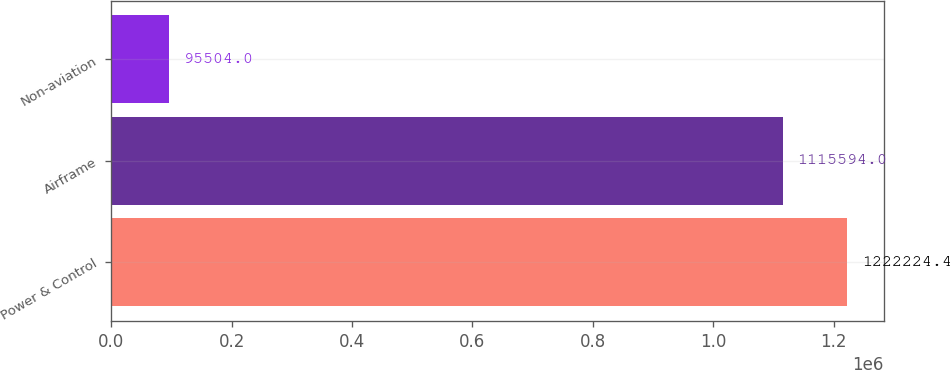<chart> <loc_0><loc_0><loc_500><loc_500><bar_chart><fcel>Power & Control<fcel>Airframe<fcel>Non-aviation<nl><fcel>1.22222e+06<fcel>1.11559e+06<fcel>95504<nl></chart> 